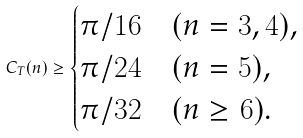<formula> <loc_0><loc_0><loc_500><loc_500>C _ { T } ( n ) \geq \begin{cases} \pi / 1 6 & ( n = 3 , 4 ) , \\ \pi / 2 4 & ( n = 5 ) , \\ \pi / 3 2 & ( n \geq 6 ) . \end{cases}</formula> 